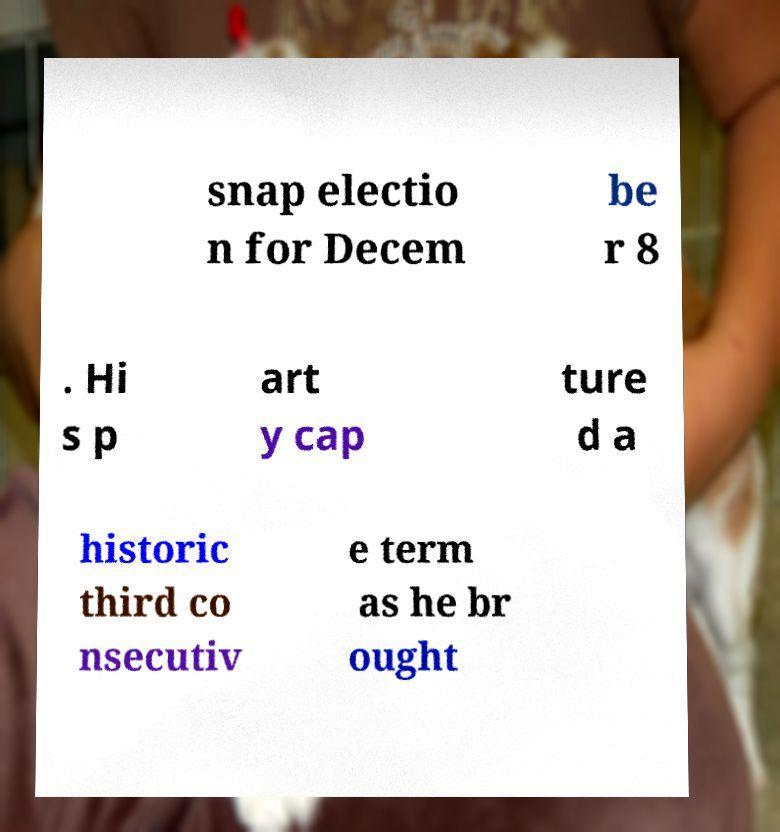There's text embedded in this image that I need extracted. Can you transcribe it verbatim? snap electio n for Decem be r 8 . Hi s p art y cap ture d a historic third co nsecutiv e term as he br ought 